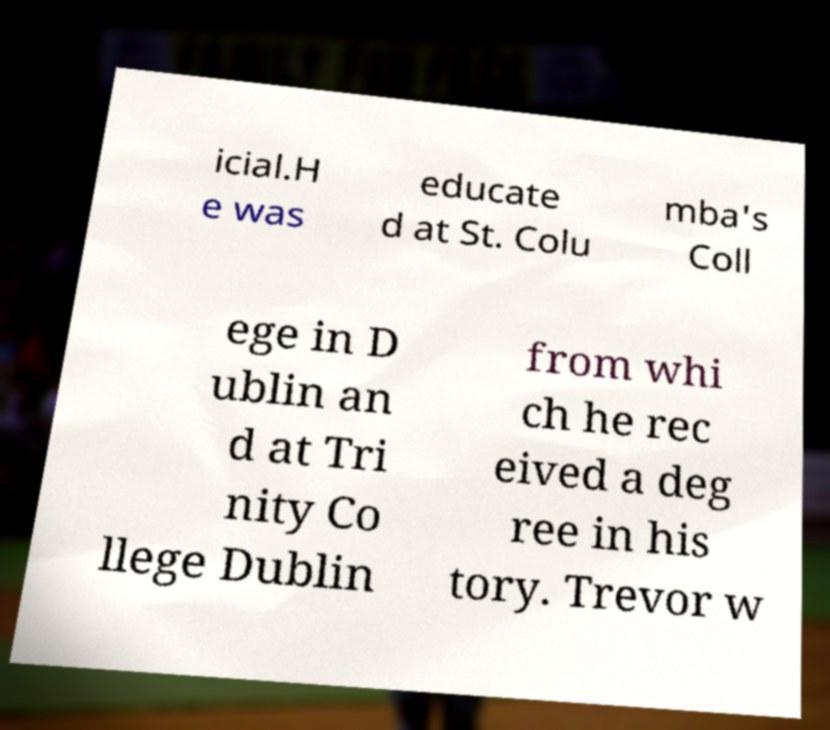Can you read and provide the text displayed in the image?This photo seems to have some interesting text. Can you extract and type it out for me? icial.H e was educate d at St. Colu mba's Coll ege in D ublin an d at Tri nity Co llege Dublin from whi ch he rec eived a deg ree in his tory. Trevor w 